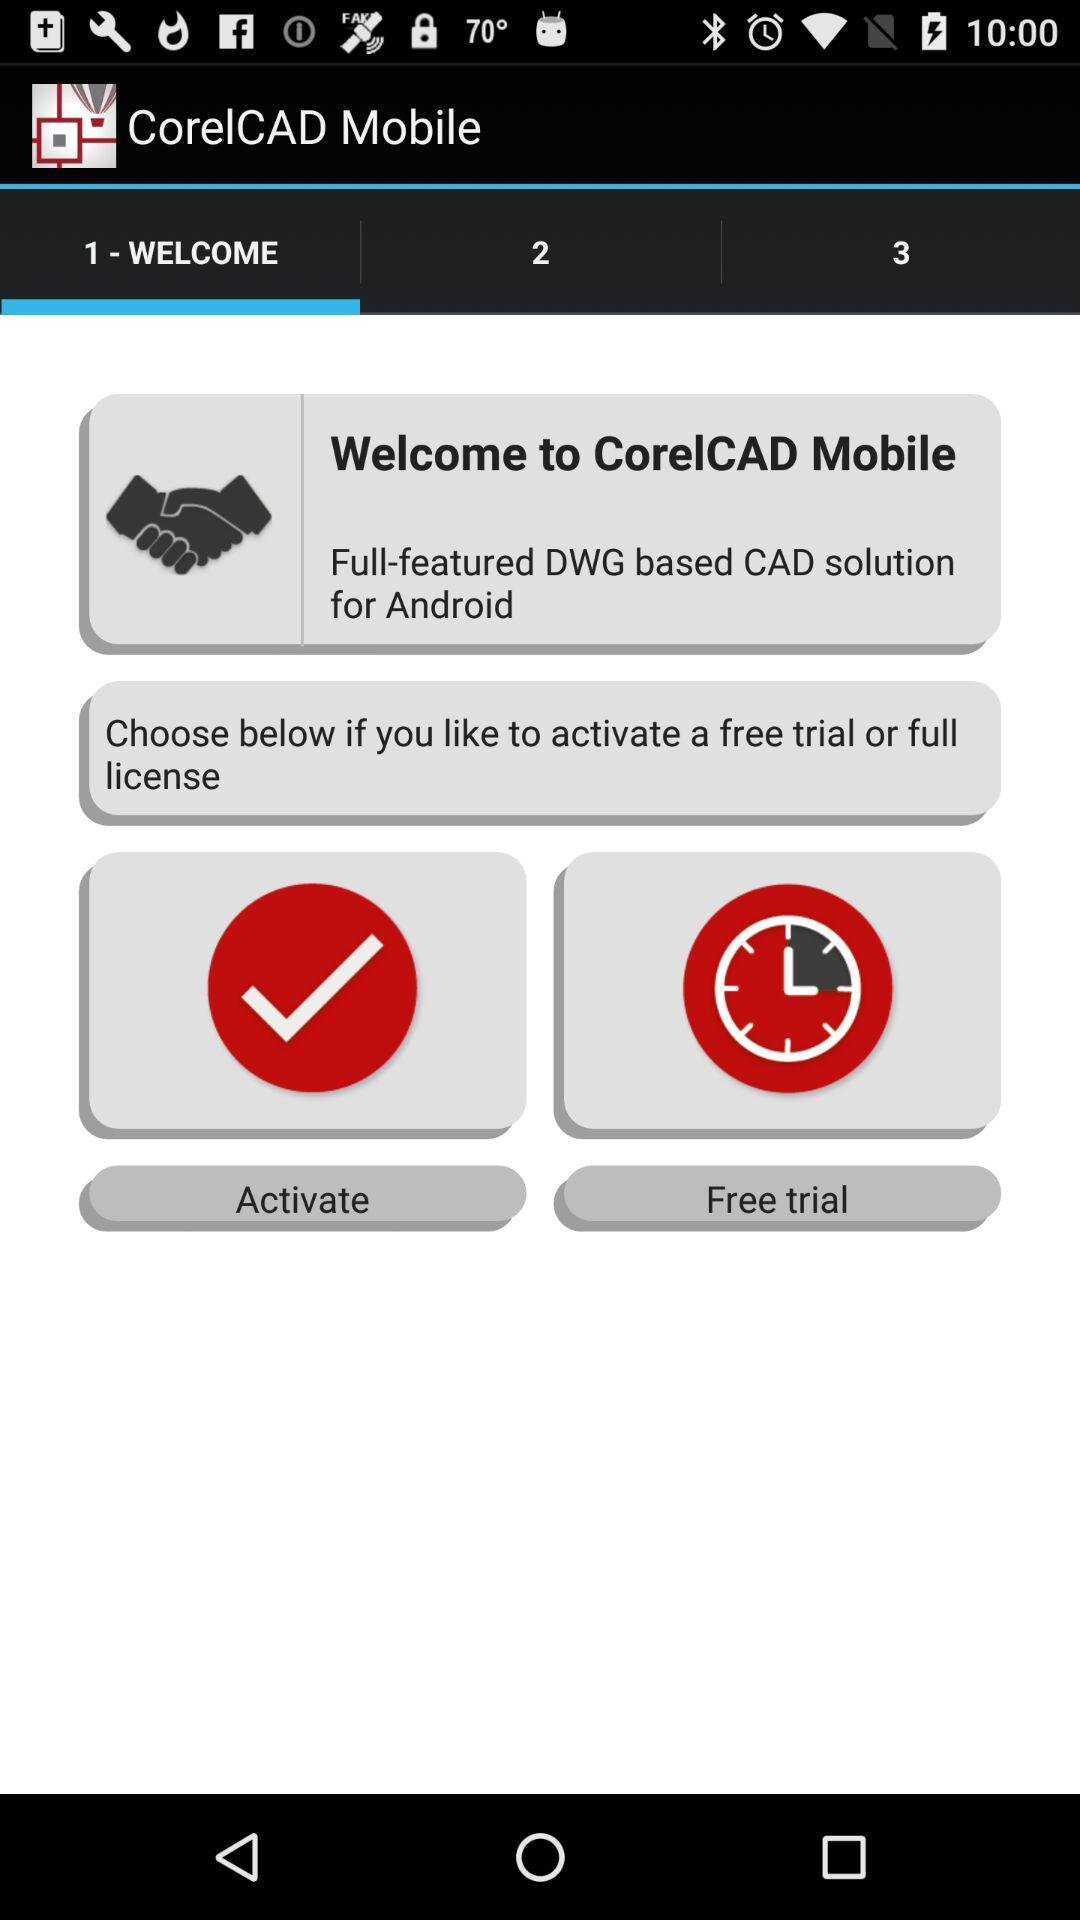What is the application name? The application name is "CorelCAD Mobile". 